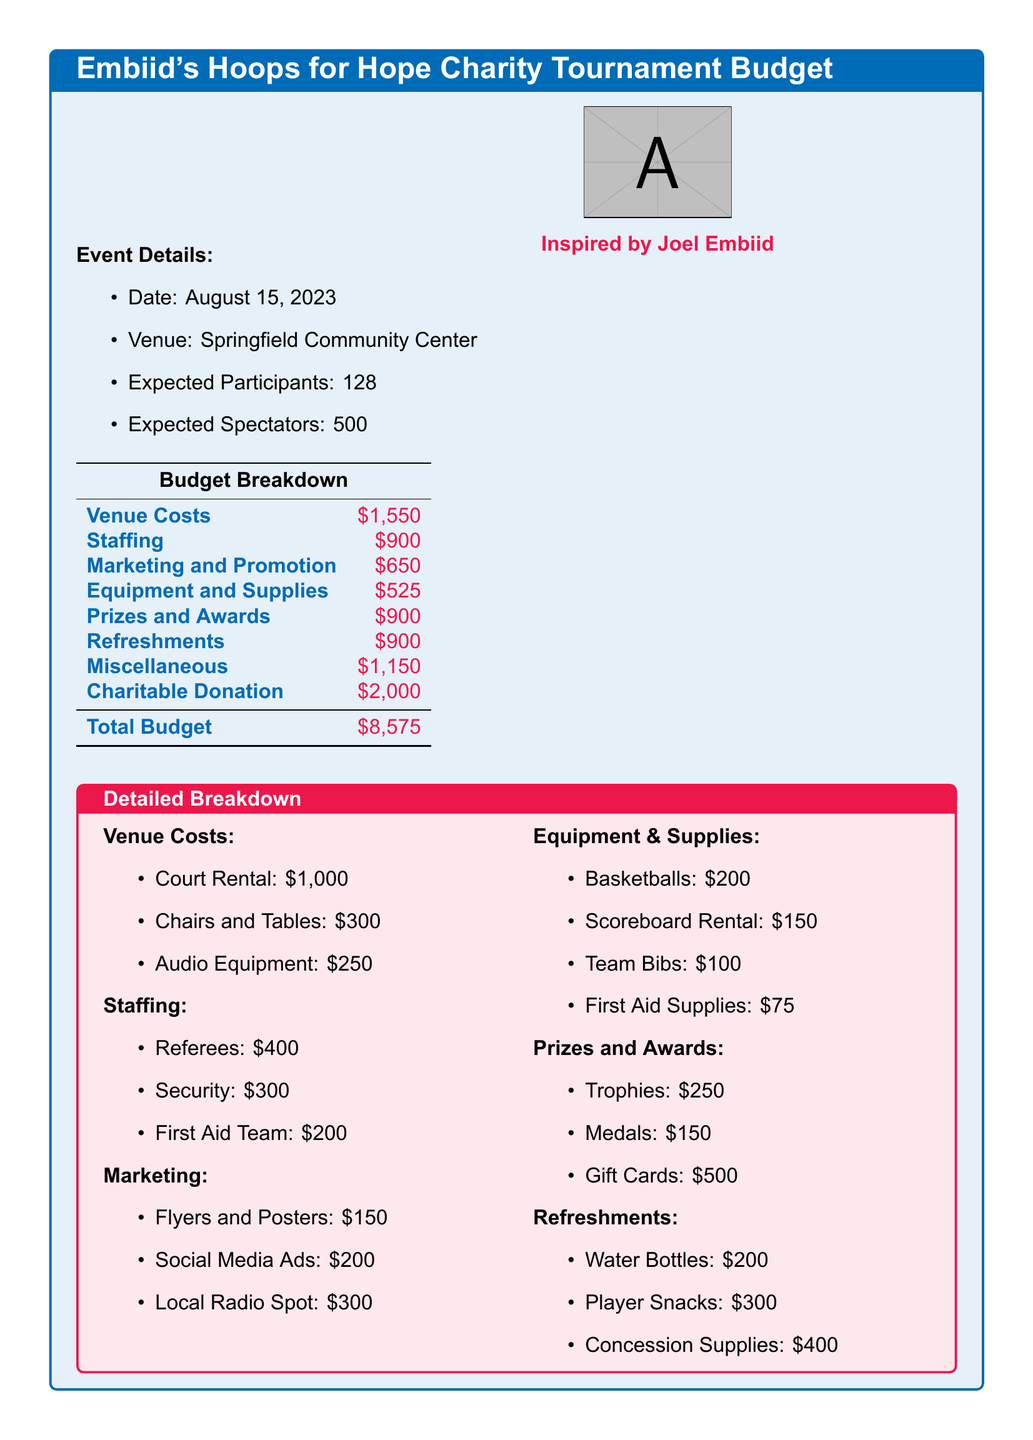What is the date of the tournament? The date of the tournament is mentioned as August 15, 2023.
Answer: August 15, 2023 What is the total budget for the event? The total budget is stated as the sum of all cost categories listed in the budget breakdown, which equals 8575 dollars.
Answer: $8,575 How many expected participants are there? The expected participants are noted under event details, which states 128 participants.
Answer: 128 What are the staffing costs? Staffing costs are detailed under the budget breakdown, which shows a total of 900 dollars for staffing.
Answer: $900 What is the cost for prizes and awards? The budget breakdown specifies the cost allocated for prizes and awards as 900 dollars.
Answer: $900 What is the cost for refreshments? Refreshments are allocated a budget of 900 dollars according to the budget breakdown.
Answer: $900 Which item has the highest single cost? The costs for charitable donation amount to 2000 dollars, which is the highest single expense in the budget.
Answer: $2,000 How much is allocated for marketing and promotion? The budget breakdown shows marketing and promotion costs as 650 dollars.
Answer: $650 What is the total cost for venue rental? Venue costs are detailed with rental at 1000 dollars, plus additional costs listed, summing up to 1550 dollars.
Answer: $1,550 What will the event proceeds be used for? The proceeds from the event are intended as a charitable donation, as indicated in the budget.
Answer: Charitable Donation 